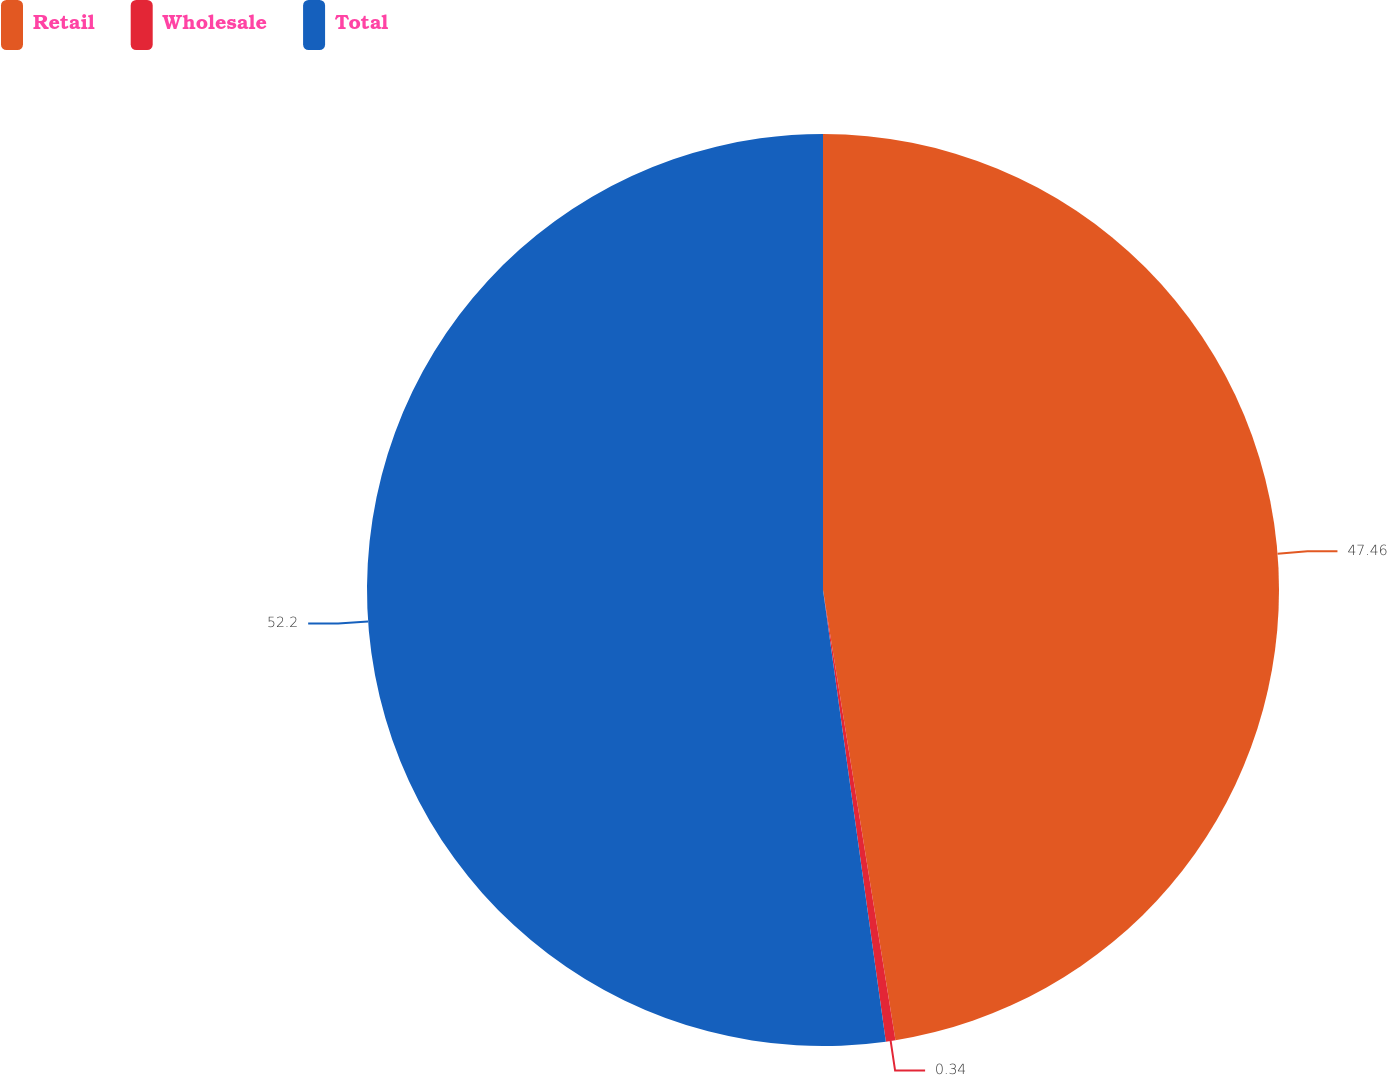Convert chart to OTSL. <chart><loc_0><loc_0><loc_500><loc_500><pie_chart><fcel>Retail<fcel>Wholesale<fcel>Total<nl><fcel>47.46%<fcel>0.34%<fcel>52.2%<nl></chart> 